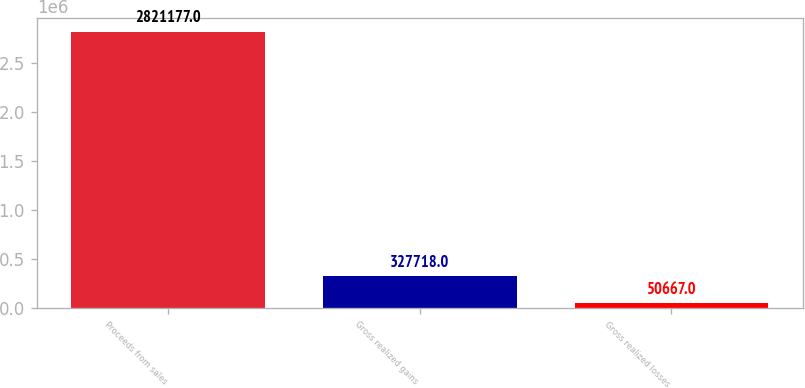Convert chart to OTSL. <chart><loc_0><loc_0><loc_500><loc_500><bar_chart><fcel>Proceeds from sales<fcel>Gross realized gains<fcel>Gross realized losses<nl><fcel>2.82118e+06<fcel>327718<fcel>50667<nl></chart> 